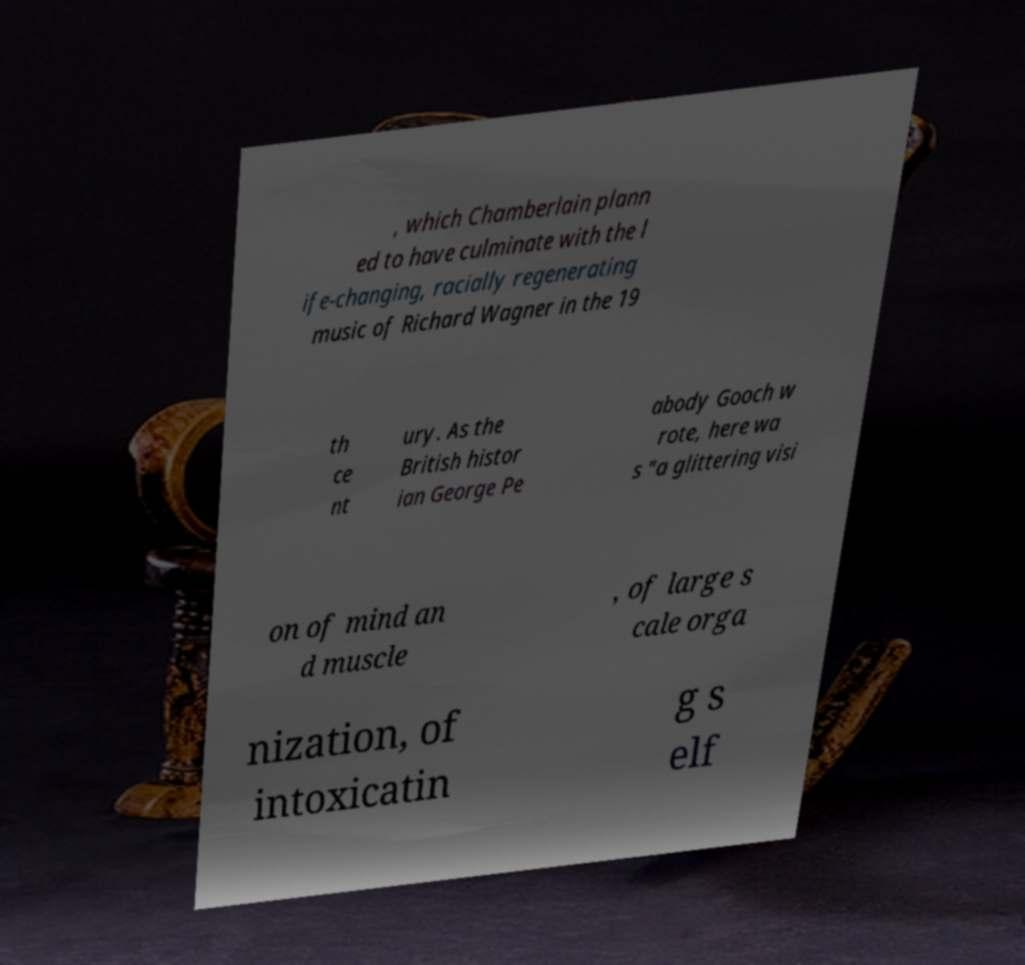Can you read and provide the text displayed in the image?This photo seems to have some interesting text. Can you extract and type it out for me? , which Chamberlain plann ed to have culminate with the l ife-changing, racially regenerating music of Richard Wagner in the 19 th ce nt ury. As the British histor ian George Pe abody Gooch w rote, here wa s "a glittering visi on of mind an d muscle , of large s cale orga nization, of intoxicatin g s elf 